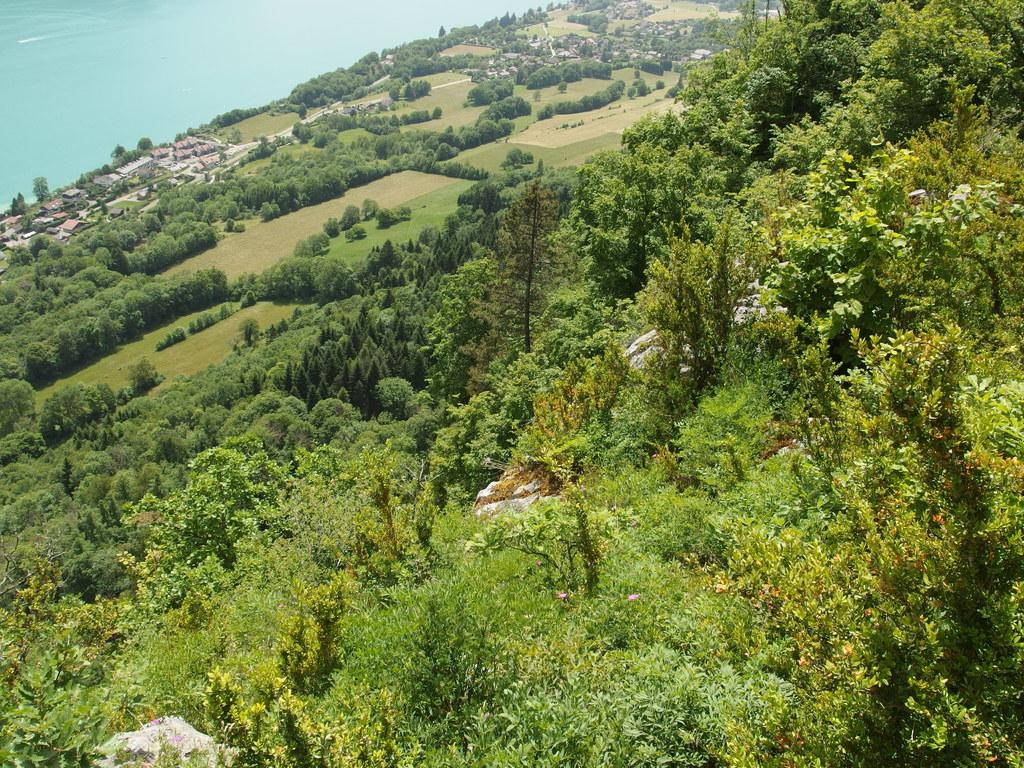What type of vegetation can be seen in the image? There are trees in the image. What type of structures are present in the image? There are houses in the image. What natural element is visible in the image? There is water visible in the image. Can you see a flock of worms in the image? There are no worms present in the image. What type of approval is being given in the image? There is no indication of any approval process or decision in the image. 